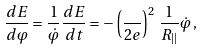Convert formula to latex. <formula><loc_0><loc_0><loc_500><loc_500>\frac { d E } { d \varphi } = \frac { 1 } { \dot { \varphi } } \frac { d E } { d t } = - \left ( \frac { } { 2 e } \right ) ^ { 2 } \, \frac { 1 } { R _ { | | } } \dot { \varphi } \, ,</formula> 